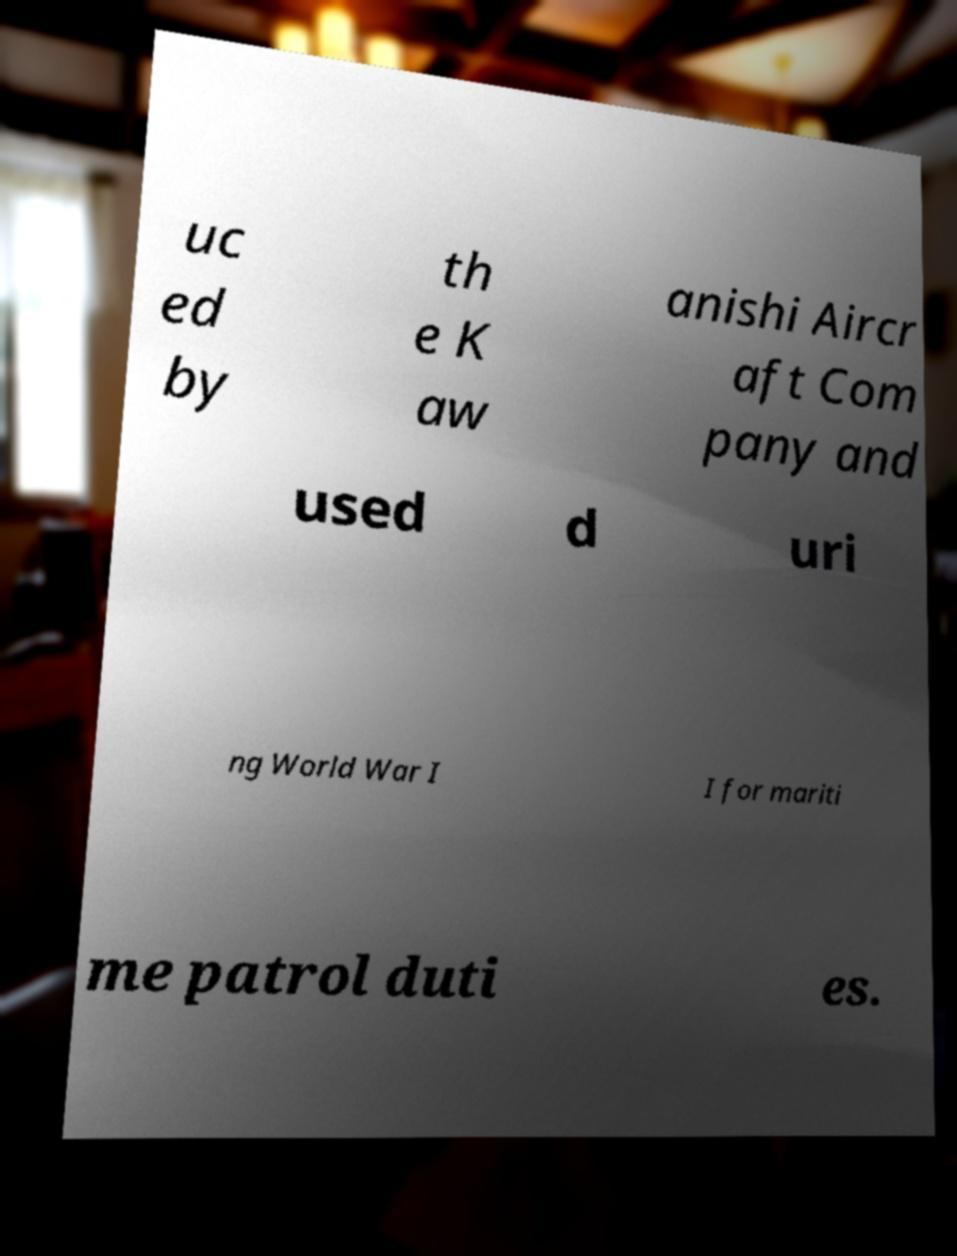Could you extract and type out the text from this image? uc ed by th e K aw anishi Aircr aft Com pany and used d uri ng World War I I for mariti me patrol duti es. 